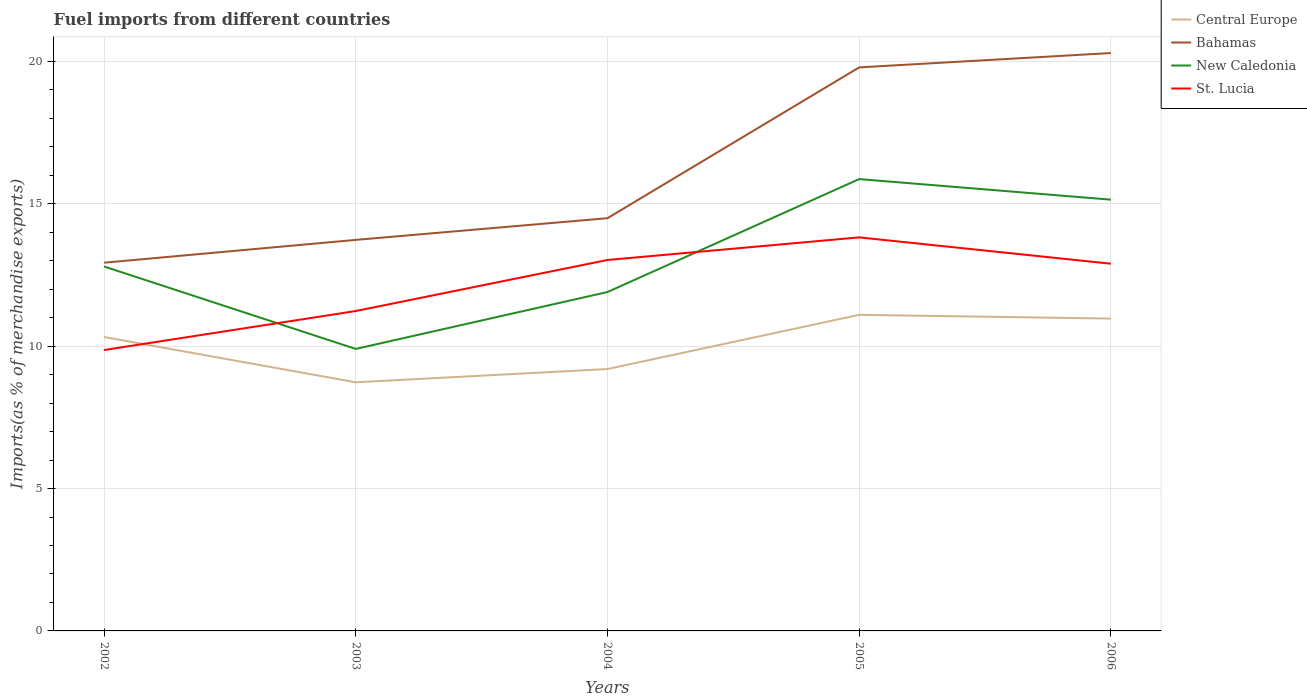How many different coloured lines are there?
Keep it short and to the point. 4. Is the number of lines equal to the number of legend labels?
Provide a succinct answer. Yes. Across all years, what is the maximum percentage of imports to different countries in New Caledonia?
Make the answer very short. 9.9. In which year was the percentage of imports to different countries in Bahamas maximum?
Your answer should be compact. 2002. What is the total percentage of imports to different countries in Bahamas in the graph?
Keep it short and to the point. -1.56. What is the difference between the highest and the second highest percentage of imports to different countries in Central Europe?
Provide a succinct answer. 2.37. Is the percentage of imports to different countries in New Caledonia strictly greater than the percentage of imports to different countries in Central Europe over the years?
Make the answer very short. No. What is the difference between two consecutive major ticks on the Y-axis?
Provide a short and direct response. 5. Are the values on the major ticks of Y-axis written in scientific E-notation?
Keep it short and to the point. No. Does the graph contain grids?
Give a very brief answer. Yes. How many legend labels are there?
Offer a terse response. 4. What is the title of the graph?
Make the answer very short. Fuel imports from different countries. What is the label or title of the X-axis?
Offer a terse response. Years. What is the label or title of the Y-axis?
Make the answer very short. Imports(as % of merchandise exports). What is the Imports(as % of merchandise exports) in Central Europe in 2002?
Make the answer very short. 10.32. What is the Imports(as % of merchandise exports) of Bahamas in 2002?
Provide a short and direct response. 12.93. What is the Imports(as % of merchandise exports) in New Caledonia in 2002?
Ensure brevity in your answer.  12.8. What is the Imports(as % of merchandise exports) in St. Lucia in 2002?
Your answer should be very brief. 9.86. What is the Imports(as % of merchandise exports) of Central Europe in 2003?
Your answer should be very brief. 8.73. What is the Imports(as % of merchandise exports) of Bahamas in 2003?
Provide a short and direct response. 13.73. What is the Imports(as % of merchandise exports) in New Caledonia in 2003?
Ensure brevity in your answer.  9.9. What is the Imports(as % of merchandise exports) of St. Lucia in 2003?
Give a very brief answer. 11.23. What is the Imports(as % of merchandise exports) in Central Europe in 2004?
Provide a short and direct response. 9.2. What is the Imports(as % of merchandise exports) of Bahamas in 2004?
Offer a very short reply. 14.49. What is the Imports(as % of merchandise exports) of New Caledonia in 2004?
Give a very brief answer. 11.9. What is the Imports(as % of merchandise exports) in St. Lucia in 2004?
Offer a terse response. 13.03. What is the Imports(as % of merchandise exports) of Central Europe in 2005?
Your response must be concise. 11.1. What is the Imports(as % of merchandise exports) of Bahamas in 2005?
Provide a short and direct response. 19.79. What is the Imports(as % of merchandise exports) of New Caledonia in 2005?
Provide a succinct answer. 15.87. What is the Imports(as % of merchandise exports) of St. Lucia in 2005?
Keep it short and to the point. 13.82. What is the Imports(as % of merchandise exports) of Central Europe in 2006?
Ensure brevity in your answer.  10.97. What is the Imports(as % of merchandise exports) in Bahamas in 2006?
Your response must be concise. 20.29. What is the Imports(as % of merchandise exports) in New Caledonia in 2006?
Give a very brief answer. 15.15. What is the Imports(as % of merchandise exports) of St. Lucia in 2006?
Provide a succinct answer. 12.9. Across all years, what is the maximum Imports(as % of merchandise exports) of Central Europe?
Provide a short and direct response. 11.1. Across all years, what is the maximum Imports(as % of merchandise exports) of Bahamas?
Your answer should be compact. 20.29. Across all years, what is the maximum Imports(as % of merchandise exports) in New Caledonia?
Keep it short and to the point. 15.87. Across all years, what is the maximum Imports(as % of merchandise exports) in St. Lucia?
Make the answer very short. 13.82. Across all years, what is the minimum Imports(as % of merchandise exports) of Central Europe?
Offer a terse response. 8.73. Across all years, what is the minimum Imports(as % of merchandise exports) in Bahamas?
Offer a very short reply. 12.93. Across all years, what is the minimum Imports(as % of merchandise exports) in New Caledonia?
Make the answer very short. 9.9. Across all years, what is the minimum Imports(as % of merchandise exports) in St. Lucia?
Provide a short and direct response. 9.86. What is the total Imports(as % of merchandise exports) in Central Europe in the graph?
Keep it short and to the point. 50.32. What is the total Imports(as % of merchandise exports) of Bahamas in the graph?
Make the answer very short. 81.24. What is the total Imports(as % of merchandise exports) in New Caledonia in the graph?
Provide a short and direct response. 65.62. What is the total Imports(as % of merchandise exports) of St. Lucia in the graph?
Offer a terse response. 60.84. What is the difference between the Imports(as % of merchandise exports) of Central Europe in 2002 and that in 2003?
Offer a terse response. 1.59. What is the difference between the Imports(as % of merchandise exports) in Bahamas in 2002 and that in 2003?
Your answer should be compact. -0.8. What is the difference between the Imports(as % of merchandise exports) in New Caledonia in 2002 and that in 2003?
Make the answer very short. 2.9. What is the difference between the Imports(as % of merchandise exports) in St. Lucia in 2002 and that in 2003?
Your response must be concise. -1.37. What is the difference between the Imports(as % of merchandise exports) in Central Europe in 2002 and that in 2004?
Ensure brevity in your answer.  1.12. What is the difference between the Imports(as % of merchandise exports) of Bahamas in 2002 and that in 2004?
Keep it short and to the point. -1.56. What is the difference between the Imports(as % of merchandise exports) in New Caledonia in 2002 and that in 2004?
Provide a short and direct response. 0.9. What is the difference between the Imports(as % of merchandise exports) in St. Lucia in 2002 and that in 2004?
Ensure brevity in your answer.  -3.16. What is the difference between the Imports(as % of merchandise exports) of Central Europe in 2002 and that in 2005?
Provide a succinct answer. -0.78. What is the difference between the Imports(as % of merchandise exports) of Bahamas in 2002 and that in 2005?
Give a very brief answer. -6.86. What is the difference between the Imports(as % of merchandise exports) of New Caledonia in 2002 and that in 2005?
Your answer should be compact. -3.07. What is the difference between the Imports(as % of merchandise exports) in St. Lucia in 2002 and that in 2005?
Keep it short and to the point. -3.96. What is the difference between the Imports(as % of merchandise exports) of Central Europe in 2002 and that in 2006?
Provide a short and direct response. -0.65. What is the difference between the Imports(as % of merchandise exports) of Bahamas in 2002 and that in 2006?
Your answer should be compact. -7.36. What is the difference between the Imports(as % of merchandise exports) in New Caledonia in 2002 and that in 2006?
Your answer should be compact. -2.35. What is the difference between the Imports(as % of merchandise exports) of St. Lucia in 2002 and that in 2006?
Keep it short and to the point. -3.03. What is the difference between the Imports(as % of merchandise exports) of Central Europe in 2003 and that in 2004?
Keep it short and to the point. -0.47. What is the difference between the Imports(as % of merchandise exports) in Bahamas in 2003 and that in 2004?
Your response must be concise. -0.76. What is the difference between the Imports(as % of merchandise exports) of New Caledonia in 2003 and that in 2004?
Provide a short and direct response. -2. What is the difference between the Imports(as % of merchandise exports) of St. Lucia in 2003 and that in 2004?
Your answer should be compact. -1.79. What is the difference between the Imports(as % of merchandise exports) of Central Europe in 2003 and that in 2005?
Offer a very short reply. -2.37. What is the difference between the Imports(as % of merchandise exports) of Bahamas in 2003 and that in 2005?
Your answer should be compact. -6.06. What is the difference between the Imports(as % of merchandise exports) in New Caledonia in 2003 and that in 2005?
Your answer should be compact. -5.96. What is the difference between the Imports(as % of merchandise exports) of St. Lucia in 2003 and that in 2005?
Your answer should be very brief. -2.59. What is the difference between the Imports(as % of merchandise exports) of Central Europe in 2003 and that in 2006?
Keep it short and to the point. -2.24. What is the difference between the Imports(as % of merchandise exports) of Bahamas in 2003 and that in 2006?
Provide a succinct answer. -6.56. What is the difference between the Imports(as % of merchandise exports) of New Caledonia in 2003 and that in 2006?
Offer a terse response. -5.24. What is the difference between the Imports(as % of merchandise exports) in St. Lucia in 2003 and that in 2006?
Your answer should be compact. -1.66. What is the difference between the Imports(as % of merchandise exports) in Central Europe in 2004 and that in 2005?
Provide a succinct answer. -1.9. What is the difference between the Imports(as % of merchandise exports) of Bahamas in 2004 and that in 2005?
Ensure brevity in your answer.  -5.3. What is the difference between the Imports(as % of merchandise exports) of New Caledonia in 2004 and that in 2005?
Your answer should be very brief. -3.97. What is the difference between the Imports(as % of merchandise exports) of St. Lucia in 2004 and that in 2005?
Ensure brevity in your answer.  -0.79. What is the difference between the Imports(as % of merchandise exports) of Central Europe in 2004 and that in 2006?
Your response must be concise. -1.77. What is the difference between the Imports(as % of merchandise exports) in Bahamas in 2004 and that in 2006?
Your answer should be compact. -5.8. What is the difference between the Imports(as % of merchandise exports) of New Caledonia in 2004 and that in 2006?
Give a very brief answer. -3.24. What is the difference between the Imports(as % of merchandise exports) of St. Lucia in 2004 and that in 2006?
Keep it short and to the point. 0.13. What is the difference between the Imports(as % of merchandise exports) of Central Europe in 2005 and that in 2006?
Ensure brevity in your answer.  0.13. What is the difference between the Imports(as % of merchandise exports) in Bahamas in 2005 and that in 2006?
Provide a short and direct response. -0.5. What is the difference between the Imports(as % of merchandise exports) of New Caledonia in 2005 and that in 2006?
Keep it short and to the point. 0.72. What is the difference between the Imports(as % of merchandise exports) in St. Lucia in 2005 and that in 2006?
Provide a short and direct response. 0.92. What is the difference between the Imports(as % of merchandise exports) of Central Europe in 2002 and the Imports(as % of merchandise exports) of Bahamas in 2003?
Your answer should be compact. -3.41. What is the difference between the Imports(as % of merchandise exports) of Central Europe in 2002 and the Imports(as % of merchandise exports) of New Caledonia in 2003?
Your answer should be compact. 0.42. What is the difference between the Imports(as % of merchandise exports) in Central Europe in 2002 and the Imports(as % of merchandise exports) in St. Lucia in 2003?
Ensure brevity in your answer.  -0.91. What is the difference between the Imports(as % of merchandise exports) in Bahamas in 2002 and the Imports(as % of merchandise exports) in New Caledonia in 2003?
Your response must be concise. 3.03. What is the difference between the Imports(as % of merchandise exports) in Bahamas in 2002 and the Imports(as % of merchandise exports) in St. Lucia in 2003?
Ensure brevity in your answer.  1.7. What is the difference between the Imports(as % of merchandise exports) in New Caledonia in 2002 and the Imports(as % of merchandise exports) in St. Lucia in 2003?
Ensure brevity in your answer.  1.56. What is the difference between the Imports(as % of merchandise exports) in Central Europe in 2002 and the Imports(as % of merchandise exports) in Bahamas in 2004?
Provide a short and direct response. -4.17. What is the difference between the Imports(as % of merchandise exports) of Central Europe in 2002 and the Imports(as % of merchandise exports) of New Caledonia in 2004?
Offer a terse response. -1.58. What is the difference between the Imports(as % of merchandise exports) in Central Europe in 2002 and the Imports(as % of merchandise exports) in St. Lucia in 2004?
Provide a short and direct response. -2.71. What is the difference between the Imports(as % of merchandise exports) of Bahamas in 2002 and the Imports(as % of merchandise exports) of New Caledonia in 2004?
Provide a succinct answer. 1.03. What is the difference between the Imports(as % of merchandise exports) of Bahamas in 2002 and the Imports(as % of merchandise exports) of St. Lucia in 2004?
Offer a terse response. -0.1. What is the difference between the Imports(as % of merchandise exports) in New Caledonia in 2002 and the Imports(as % of merchandise exports) in St. Lucia in 2004?
Your answer should be compact. -0.23. What is the difference between the Imports(as % of merchandise exports) of Central Europe in 2002 and the Imports(as % of merchandise exports) of Bahamas in 2005?
Provide a short and direct response. -9.47. What is the difference between the Imports(as % of merchandise exports) in Central Europe in 2002 and the Imports(as % of merchandise exports) in New Caledonia in 2005?
Your answer should be very brief. -5.55. What is the difference between the Imports(as % of merchandise exports) in Central Europe in 2002 and the Imports(as % of merchandise exports) in St. Lucia in 2005?
Keep it short and to the point. -3.5. What is the difference between the Imports(as % of merchandise exports) of Bahamas in 2002 and the Imports(as % of merchandise exports) of New Caledonia in 2005?
Provide a short and direct response. -2.94. What is the difference between the Imports(as % of merchandise exports) in Bahamas in 2002 and the Imports(as % of merchandise exports) in St. Lucia in 2005?
Your answer should be compact. -0.89. What is the difference between the Imports(as % of merchandise exports) of New Caledonia in 2002 and the Imports(as % of merchandise exports) of St. Lucia in 2005?
Offer a very short reply. -1.02. What is the difference between the Imports(as % of merchandise exports) of Central Europe in 2002 and the Imports(as % of merchandise exports) of Bahamas in 2006?
Your response must be concise. -9.97. What is the difference between the Imports(as % of merchandise exports) of Central Europe in 2002 and the Imports(as % of merchandise exports) of New Caledonia in 2006?
Provide a succinct answer. -4.82. What is the difference between the Imports(as % of merchandise exports) of Central Europe in 2002 and the Imports(as % of merchandise exports) of St. Lucia in 2006?
Give a very brief answer. -2.57. What is the difference between the Imports(as % of merchandise exports) in Bahamas in 2002 and the Imports(as % of merchandise exports) in New Caledonia in 2006?
Offer a very short reply. -2.21. What is the difference between the Imports(as % of merchandise exports) in Bahamas in 2002 and the Imports(as % of merchandise exports) in St. Lucia in 2006?
Provide a short and direct response. 0.04. What is the difference between the Imports(as % of merchandise exports) in New Caledonia in 2002 and the Imports(as % of merchandise exports) in St. Lucia in 2006?
Your answer should be compact. -0.1. What is the difference between the Imports(as % of merchandise exports) of Central Europe in 2003 and the Imports(as % of merchandise exports) of Bahamas in 2004?
Make the answer very short. -5.76. What is the difference between the Imports(as % of merchandise exports) in Central Europe in 2003 and the Imports(as % of merchandise exports) in New Caledonia in 2004?
Your answer should be very brief. -3.17. What is the difference between the Imports(as % of merchandise exports) in Central Europe in 2003 and the Imports(as % of merchandise exports) in St. Lucia in 2004?
Provide a succinct answer. -4.3. What is the difference between the Imports(as % of merchandise exports) of Bahamas in 2003 and the Imports(as % of merchandise exports) of New Caledonia in 2004?
Provide a succinct answer. 1.83. What is the difference between the Imports(as % of merchandise exports) in Bahamas in 2003 and the Imports(as % of merchandise exports) in St. Lucia in 2004?
Make the answer very short. 0.71. What is the difference between the Imports(as % of merchandise exports) of New Caledonia in 2003 and the Imports(as % of merchandise exports) of St. Lucia in 2004?
Give a very brief answer. -3.12. What is the difference between the Imports(as % of merchandise exports) of Central Europe in 2003 and the Imports(as % of merchandise exports) of Bahamas in 2005?
Your answer should be compact. -11.06. What is the difference between the Imports(as % of merchandise exports) in Central Europe in 2003 and the Imports(as % of merchandise exports) in New Caledonia in 2005?
Give a very brief answer. -7.14. What is the difference between the Imports(as % of merchandise exports) of Central Europe in 2003 and the Imports(as % of merchandise exports) of St. Lucia in 2005?
Your answer should be very brief. -5.09. What is the difference between the Imports(as % of merchandise exports) in Bahamas in 2003 and the Imports(as % of merchandise exports) in New Caledonia in 2005?
Give a very brief answer. -2.13. What is the difference between the Imports(as % of merchandise exports) of Bahamas in 2003 and the Imports(as % of merchandise exports) of St. Lucia in 2005?
Your answer should be compact. -0.09. What is the difference between the Imports(as % of merchandise exports) in New Caledonia in 2003 and the Imports(as % of merchandise exports) in St. Lucia in 2005?
Keep it short and to the point. -3.92. What is the difference between the Imports(as % of merchandise exports) in Central Europe in 2003 and the Imports(as % of merchandise exports) in Bahamas in 2006?
Your answer should be compact. -11.56. What is the difference between the Imports(as % of merchandise exports) in Central Europe in 2003 and the Imports(as % of merchandise exports) in New Caledonia in 2006?
Provide a succinct answer. -6.41. What is the difference between the Imports(as % of merchandise exports) in Central Europe in 2003 and the Imports(as % of merchandise exports) in St. Lucia in 2006?
Your response must be concise. -4.16. What is the difference between the Imports(as % of merchandise exports) in Bahamas in 2003 and the Imports(as % of merchandise exports) in New Caledonia in 2006?
Your answer should be compact. -1.41. What is the difference between the Imports(as % of merchandise exports) of Bahamas in 2003 and the Imports(as % of merchandise exports) of St. Lucia in 2006?
Ensure brevity in your answer.  0.84. What is the difference between the Imports(as % of merchandise exports) in New Caledonia in 2003 and the Imports(as % of merchandise exports) in St. Lucia in 2006?
Your response must be concise. -2.99. What is the difference between the Imports(as % of merchandise exports) in Central Europe in 2004 and the Imports(as % of merchandise exports) in Bahamas in 2005?
Ensure brevity in your answer.  -10.59. What is the difference between the Imports(as % of merchandise exports) in Central Europe in 2004 and the Imports(as % of merchandise exports) in New Caledonia in 2005?
Offer a terse response. -6.67. What is the difference between the Imports(as % of merchandise exports) of Central Europe in 2004 and the Imports(as % of merchandise exports) of St. Lucia in 2005?
Ensure brevity in your answer.  -4.62. What is the difference between the Imports(as % of merchandise exports) of Bahamas in 2004 and the Imports(as % of merchandise exports) of New Caledonia in 2005?
Your answer should be very brief. -1.37. What is the difference between the Imports(as % of merchandise exports) of Bahamas in 2004 and the Imports(as % of merchandise exports) of St. Lucia in 2005?
Your answer should be very brief. 0.67. What is the difference between the Imports(as % of merchandise exports) of New Caledonia in 2004 and the Imports(as % of merchandise exports) of St. Lucia in 2005?
Make the answer very short. -1.92. What is the difference between the Imports(as % of merchandise exports) of Central Europe in 2004 and the Imports(as % of merchandise exports) of Bahamas in 2006?
Your answer should be very brief. -11.1. What is the difference between the Imports(as % of merchandise exports) of Central Europe in 2004 and the Imports(as % of merchandise exports) of New Caledonia in 2006?
Give a very brief answer. -5.95. What is the difference between the Imports(as % of merchandise exports) in Central Europe in 2004 and the Imports(as % of merchandise exports) in St. Lucia in 2006?
Give a very brief answer. -3.7. What is the difference between the Imports(as % of merchandise exports) of Bahamas in 2004 and the Imports(as % of merchandise exports) of New Caledonia in 2006?
Keep it short and to the point. -0.65. What is the difference between the Imports(as % of merchandise exports) in Bahamas in 2004 and the Imports(as % of merchandise exports) in St. Lucia in 2006?
Offer a terse response. 1.6. What is the difference between the Imports(as % of merchandise exports) of New Caledonia in 2004 and the Imports(as % of merchandise exports) of St. Lucia in 2006?
Give a very brief answer. -0.99. What is the difference between the Imports(as % of merchandise exports) in Central Europe in 2005 and the Imports(as % of merchandise exports) in Bahamas in 2006?
Make the answer very short. -9.19. What is the difference between the Imports(as % of merchandise exports) of Central Europe in 2005 and the Imports(as % of merchandise exports) of New Caledonia in 2006?
Your response must be concise. -4.04. What is the difference between the Imports(as % of merchandise exports) in Central Europe in 2005 and the Imports(as % of merchandise exports) in St. Lucia in 2006?
Give a very brief answer. -1.79. What is the difference between the Imports(as % of merchandise exports) of Bahamas in 2005 and the Imports(as % of merchandise exports) of New Caledonia in 2006?
Make the answer very short. 4.65. What is the difference between the Imports(as % of merchandise exports) in Bahamas in 2005 and the Imports(as % of merchandise exports) in St. Lucia in 2006?
Make the answer very short. 6.89. What is the difference between the Imports(as % of merchandise exports) of New Caledonia in 2005 and the Imports(as % of merchandise exports) of St. Lucia in 2006?
Make the answer very short. 2.97. What is the average Imports(as % of merchandise exports) of Central Europe per year?
Offer a terse response. 10.06. What is the average Imports(as % of merchandise exports) of Bahamas per year?
Your answer should be compact. 16.25. What is the average Imports(as % of merchandise exports) in New Caledonia per year?
Your response must be concise. 13.12. What is the average Imports(as % of merchandise exports) of St. Lucia per year?
Ensure brevity in your answer.  12.17. In the year 2002, what is the difference between the Imports(as % of merchandise exports) of Central Europe and Imports(as % of merchandise exports) of Bahamas?
Provide a succinct answer. -2.61. In the year 2002, what is the difference between the Imports(as % of merchandise exports) of Central Europe and Imports(as % of merchandise exports) of New Caledonia?
Your response must be concise. -2.48. In the year 2002, what is the difference between the Imports(as % of merchandise exports) in Central Europe and Imports(as % of merchandise exports) in St. Lucia?
Make the answer very short. 0.46. In the year 2002, what is the difference between the Imports(as % of merchandise exports) of Bahamas and Imports(as % of merchandise exports) of New Caledonia?
Ensure brevity in your answer.  0.13. In the year 2002, what is the difference between the Imports(as % of merchandise exports) of Bahamas and Imports(as % of merchandise exports) of St. Lucia?
Make the answer very short. 3.07. In the year 2002, what is the difference between the Imports(as % of merchandise exports) of New Caledonia and Imports(as % of merchandise exports) of St. Lucia?
Keep it short and to the point. 2.93. In the year 2003, what is the difference between the Imports(as % of merchandise exports) in Central Europe and Imports(as % of merchandise exports) in Bahamas?
Keep it short and to the point. -5. In the year 2003, what is the difference between the Imports(as % of merchandise exports) in Central Europe and Imports(as % of merchandise exports) in New Caledonia?
Give a very brief answer. -1.17. In the year 2003, what is the difference between the Imports(as % of merchandise exports) in Central Europe and Imports(as % of merchandise exports) in St. Lucia?
Keep it short and to the point. -2.5. In the year 2003, what is the difference between the Imports(as % of merchandise exports) in Bahamas and Imports(as % of merchandise exports) in New Caledonia?
Offer a very short reply. 3.83. In the year 2003, what is the difference between the Imports(as % of merchandise exports) of Bahamas and Imports(as % of merchandise exports) of St. Lucia?
Provide a succinct answer. 2.5. In the year 2003, what is the difference between the Imports(as % of merchandise exports) of New Caledonia and Imports(as % of merchandise exports) of St. Lucia?
Make the answer very short. -1.33. In the year 2004, what is the difference between the Imports(as % of merchandise exports) of Central Europe and Imports(as % of merchandise exports) of Bahamas?
Give a very brief answer. -5.3. In the year 2004, what is the difference between the Imports(as % of merchandise exports) of Central Europe and Imports(as % of merchandise exports) of New Caledonia?
Your response must be concise. -2.7. In the year 2004, what is the difference between the Imports(as % of merchandise exports) in Central Europe and Imports(as % of merchandise exports) in St. Lucia?
Offer a very short reply. -3.83. In the year 2004, what is the difference between the Imports(as % of merchandise exports) in Bahamas and Imports(as % of merchandise exports) in New Caledonia?
Keep it short and to the point. 2.59. In the year 2004, what is the difference between the Imports(as % of merchandise exports) in Bahamas and Imports(as % of merchandise exports) in St. Lucia?
Give a very brief answer. 1.47. In the year 2004, what is the difference between the Imports(as % of merchandise exports) of New Caledonia and Imports(as % of merchandise exports) of St. Lucia?
Your response must be concise. -1.13. In the year 2005, what is the difference between the Imports(as % of merchandise exports) of Central Europe and Imports(as % of merchandise exports) of Bahamas?
Provide a short and direct response. -8.69. In the year 2005, what is the difference between the Imports(as % of merchandise exports) in Central Europe and Imports(as % of merchandise exports) in New Caledonia?
Offer a very short reply. -4.77. In the year 2005, what is the difference between the Imports(as % of merchandise exports) of Central Europe and Imports(as % of merchandise exports) of St. Lucia?
Make the answer very short. -2.72. In the year 2005, what is the difference between the Imports(as % of merchandise exports) of Bahamas and Imports(as % of merchandise exports) of New Caledonia?
Ensure brevity in your answer.  3.92. In the year 2005, what is the difference between the Imports(as % of merchandise exports) in Bahamas and Imports(as % of merchandise exports) in St. Lucia?
Offer a very short reply. 5.97. In the year 2005, what is the difference between the Imports(as % of merchandise exports) of New Caledonia and Imports(as % of merchandise exports) of St. Lucia?
Your answer should be very brief. 2.05. In the year 2006, what is the difference between the Imports(as % of merchandise exports) of Central Europe and Imports(as % of merchandise exports) of Bahamas?
Your response must be concise. -9.33. In the year 2006, what is the difference between the Imports(as % of merchandise exports) of Central Europe and Imports(as % of merchandise exports) of New Caledonia?
Keep it short and to the point. -4.18. In the year 2006, what is the difference between the Imports(as % of merchandise exports) of Central Europe and Imports(as % of merchandise exports) of St. Lucia?
Make the answer very short. -1.93. In the year 2006, what is the difference between the Imports(as % of merchandise exports) of Bahamas and Imports(as % of merchandise exports) of New Caledonia?
Your answer should be very brief. 5.15. In the year 2006, what is the difference between the Imports(as % of merchandise exports) in Bahamas and Imports(as % of merchandise exports) in St. Lucia?
Your response must be concise. 7.4. In the year 2006, what is the difference between the Imports(as % of merchandise exports) in New Caledonia and Imports(as % of merchandise exports) in St. Lucia?
Provide a short and direct response. 2.25. What is the ratio of the Imports(as % of merchandise exports) of Central Europe in 2002 to that in 2003?
Make the answer very short. 1.18. What is the ratio of the Imports(as % of merchandise exports) in Bahamas in 2002 to that in 2003?
Offer a very short reply. 0.94. What is the ratio of the Imports(as % of merchandise exports) of New Caledonia in 2002 to that in 2003?
Provide a short and direct response. 1.29. What is the ratio of the Imports(as % of merchandise exports) in St. Lucia in 2002 to that in 2003?
Your response must be concise. 0.88. What is the ratio of the Imports(as % of merchandise exports) in Central Europe in 2002 to that in 2004?
Your answer should be compact. 1.12. What is the ratio of the Imports(as % of merchandise exports) in Bahamas in 2002 to that in 2004?
Make the answer very short. 0.89. What is the ratio of the Imports(as % of merchandise exports) in New Caledonia in 2002 to that in 2004?
Provide a short and direct response. 1.08. What is the ratio of the Imports(as % of merchandise exports) of St. Lucia in 2002 to that in 2004?
Your answer should be compact. 0.76. What is the ratio of the Imports(as % of merchandise exports) of Central Europe in 2002 to that in 2005?
Give a very brief answer. 0.93. What is the ratio of the Imports(as % of merchandise exports) in Bahamas in 2002 to that in 2005?
Give a very brief answer. 0.65. What is the ratio of the Imports(as % of merchandise exports) of New Caledonia in 2002 to that in 2005?
Offer a very short reply. 0.81. What is the ratio of the Imports(as % of merchandise exports) of St. Lucia in 2002 to that in 2005?
Your response must be concise. 0.71. What is the ratio of the Imports(as % of merchandise exports) of Central Europe in 2002 to that in 2006?
Offer a terse response. 0.94. What is the ratio of the Imports(as % of merchandise exports) in Bahamas in 2002 to that in 2006?
Make the answer very short. 0.64. What is the ratio of the Imports(as % of merchandise exports) in New Caledonia in 2002 to that in 2006?
Your response must be concise. 0.85. What is the ratio of the Imports(as % of merchandise exports) of St. Lucia in 2002 to that in 2006?
Offer a terse response. 0.76. What is the ratio of the Imports(as % of merchandise exports) in Central Europe in 2003 to that in 2004?
Your response must be concise. 0.95. What is the ratio of the Imports(as % of merchandise exports) in Bahamas in 2003 to that in 2004?
Keep it short and to the point. 0.95. What is the ratio of the Imports(as % of merchandise exports) in New Caledonia in 2003 to that in 2004?
Your response must be concise. 0.83. What is the ratio of the Imports(as % of merchandise exports) of St. Lucia in 2003 to that in 2004?
Your answer should be compact. 0.86. What is the ratio of the Imports(as % of merchandise exports) of Central Europe in 2003 to that in 2005?
Your answer should be compact. 0.79. What is the ratio of the Imports(as % of merchandise exports) of Bahamas in 2003 to that in 2005?
Ensure brevity in your answer.  0.69. What is the ratio of the Imports(as % of merchandise exports) of New Caledonia in 2003 to that in 2005?
Offer a very short reply. 0.62. What is the ratio of the Imports(as % of merchandise exports) in St. Lucia in 2003 to that in 2005?
Your response must be concise. 0.81. What is the ratio of the Imports(as % of merchandise exports) in Central Europe in 2003 to that in 2006?
Your answer should be compact. 0.8. What is the ratio of the Imports(as % of merchandise exports) in Bahamas in 2003 to that in 2006?
Your response must be concise. 0.68. What is the ratio of the Imports(as % of merchandise exports) of New Caledonia in 2003 to that in 2006?
Offer a terse response. 0.65. What is the ratio of the Imports(as % of merchandise exports) in St. Lucia in 2003 to that in 2006?
Offer a terse response. 0.87. What is the ratio of the Imports(as % of merchandise exports) in Central Europe in 2004 to that in 2005?
Make the answer very short. 0.83. What is the ratio of the Imports(as % of merchandise exports) of Bahamas in 2004 to that in 2005?
Give a very brief answer. 0.73. What is the ratio of the Imports(as % of merchandise exports) of New Caledonia in 2004 to that in 2005?
Keep it short and to the point. 0.75. What is the ratio of the Imports(as % of merchandise exports) in St. Lucia in 2004 to that in 2005?
Ensure brevity in your answer.  0.94. What is the ratio of the Imports(as % of merchandise exports) of Central Europe in 2004 to that in 2006?
Give a very brief answer. 0.84. What is the ratio of the Imports(as % of merchandise exports) of Bahamas in 2004 to that in 2006?
Keep it short and to the point. 0.71. What is the ratio of the Imports(as % of merchandise exports) of New Caledonia in 2004 to that in 2006?
Make the answer very short. 0.79. What is the ratio of the Imports(as % of merchandise exports) in St. Lucia in 2004 to that in 2006?
Keep it short and to the point. 1.01. What is the ratio of the Imports(as % of merchandise exports) in Central Europe in 2005 to that in 2006?
Offer a very short reply. 1.01. What is the ratio of the Imports(as % of merchandise exports) of Bahamas in 2005 to that in 2006?
Provide a short and direct response. 0.98. What is the ratio of the Imports(as % of merchandise exports) of New Caledonia in 2005 to that in 2006?
Keep it short and to the point. 1.05. What is the ratio of the Imports(as % of merchandise exports) of St. Lucia in 2005 to that in 2006?
Keep it short and to the point. 1.07. What is the difference between the highest and the second highest Imports(as % of merchandise exports) in Central Europe?
Your response must be concise. 0.13. What is the difference between the highest and the second highest Imports(as % of merchandise exports) of Bahamas?
Offer a terse response. 0.5. What is the difference between the highest and the second highest Imports(as % of merchandise exports) of New Caledonia?
Provide a succinct answer. 0.72. What is the difference between the highest and the second highest Imports(as % of merchandise exports) in St. Lucia?
Give a very brief answer. 0.79. What is the difference between the highest and the lowest Imports(as % of merchandise exports) of Central Europe?
Keep it short and to the point. 2.37. What is the difference between the highest and the lowest Imports(as % of merchandise exports) of Bahamas?
Make the answer very short. 7.36. What is the difference between the highest and the lowest Imports(as % of merchandise exports) in New Caledonia?
Your answer should be compact. 5.96. What is the difference between the highest and the lowest Imports(as % of merchandise exports) of St. Lucia?
Make the answer very short. 3.96. 